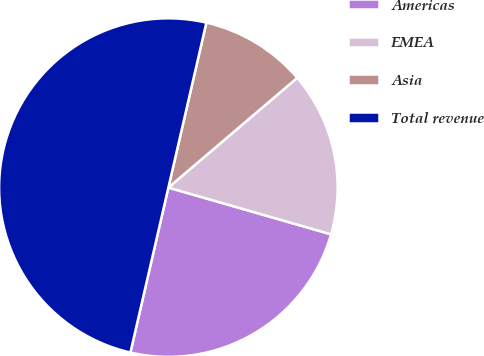Convert chart. <chart><loc_0><loc_0><loc_500><loc_500><pie_chart><fcel>Americas<fcel>EMEA<fcel>Asia<fcel>Total revenue<nl><fcel>24.15%<fcel>15.68%<fcel>10.17%<fcel>50.0%<nl></chart> 